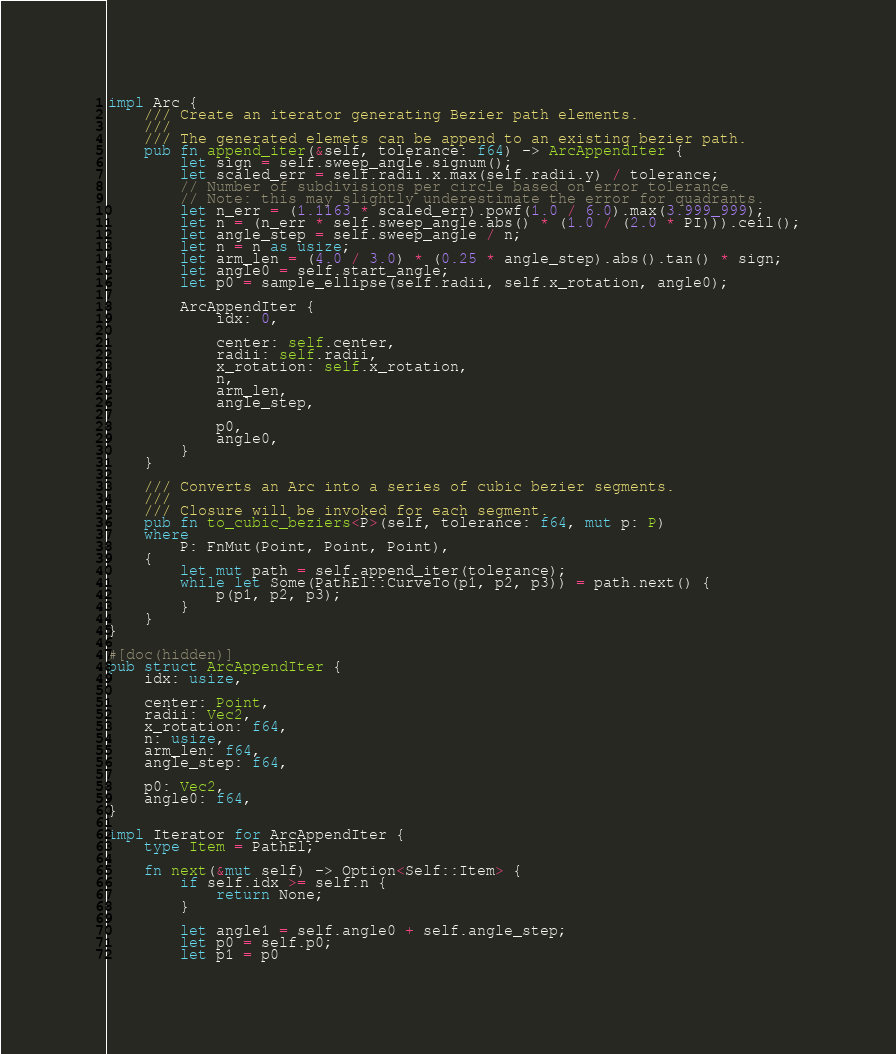<code> <loc_0><loc_0><loc_500><loc_500><_Rust_>
impl Arc {
    /// Create an iterator generating Bezier path elements.
    ///
    /// The generated elemets can be append to an existing bezier path.
    pub fn append_iter(&self, tolerance: f64) -> ArcAppendIter {
        let sign = self.sweep_angle.signum();
        let scaled_err = self.radii.x.max(self.radii.y) / tolerance;
        // Number of subdivisions per circle based on error tolerance.
        // Note: this may slightly underestimate the error for quadrants.
        let n_err = (1.1163 * scaled_err).powf(1.0 / 6.0).max(3.999_999);
        let n = (n_err * self.sweep_angle.abs() * (1.0 / (2.0 * PI))).ceil();
        let angle_step = self.sweep_angle / n;
        let n = n as usize;
        let arm_len = (4.0 / 3.0) * (0.25 * angle_step).abs().tan() * sign;
        let angle0 = self.start_angle;
        let p0 = sample_ellipse(self.radii, self.x_rotation, angle0);

        ArcAppendIter {
            idx: 0,

            center: self.center,
            radii: self.radii,
            x_rotation: self.x_rotation,
            n,
            arm_len,
            angle_step,

            p0,
            angle0,
        }
    }

    /// Converts an Arc into a series of cubic bezier segments.
    ///
    /// Closure will be invoked for each segment.
    pub fn to_cubic_beziers<P>(self, tolerance: f64, mut p: P)
    where
        P: FnMut(Point, Point, Point),
    {
        let mut path = self.append_iter(tolerance);
        while let Some(PathEl::CurveTo(p1, p2, p3)) = path.next() {
            p(p1, p2, p3);
        }
    }
}

#[doc(hidden)]
pub struct ArcAppendIter {
    idx: usize,

    center: Point,
    radii: Vec2,
    x_rotation: f64,
    n: usize,
    arm_len: f64,
    angle_step: f64,

    p0: Vec2,
    angle0: f64,
}

impl Iterator for ArcAppendIter {
    type Item = PathEl;

    fn next(&mut self) -> Option<Self::Item> {
        if self.idx >= self.n {
            return None;
        }

        let angle1 = self.angle0 + self.angle_step;
        let p0 = self.p0;
        let p1 = p0</code> 